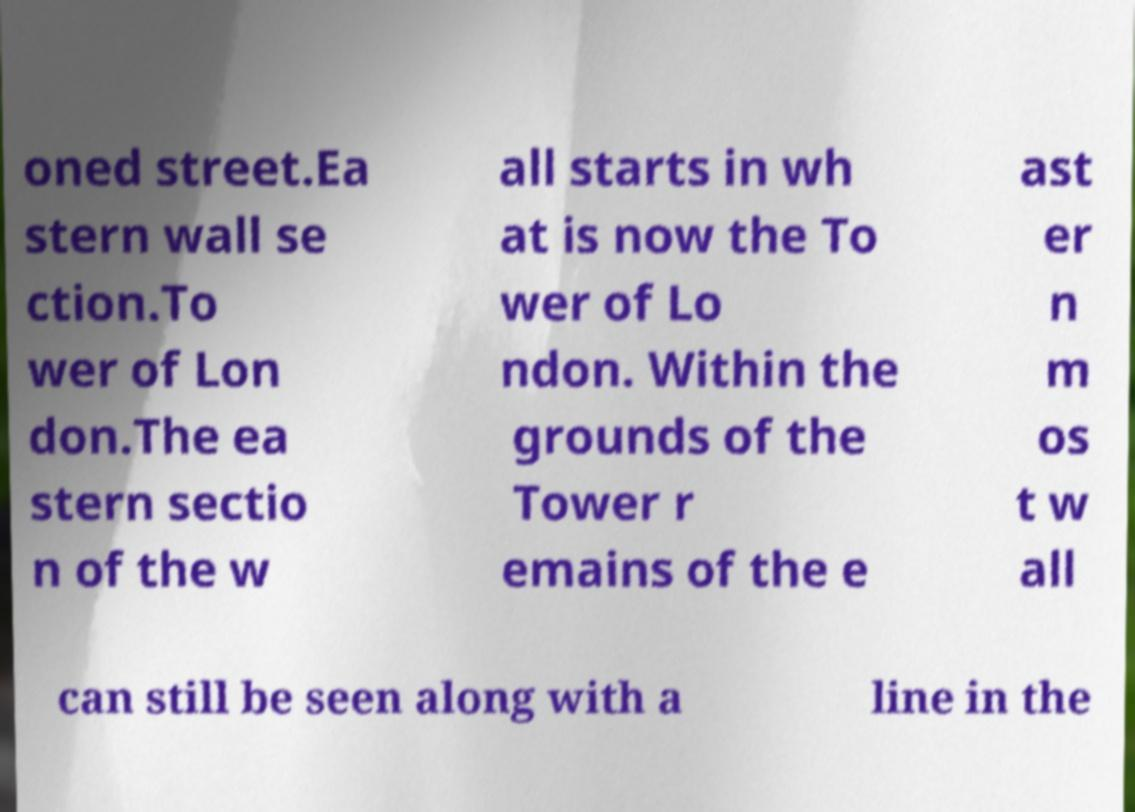Can you read and provide the text displayed in the image?This photo seems to have some interesting text. Can you extract and type it out for me? oned street.Ea stern wall se ction.To wer of Lon don.The ea stern sectio n of the w all starts in wh at is now the To wer of Lo ndon. Within the grounds of the Tower r emains of the e ast er n m os t w all can still be seen along with a line in the 